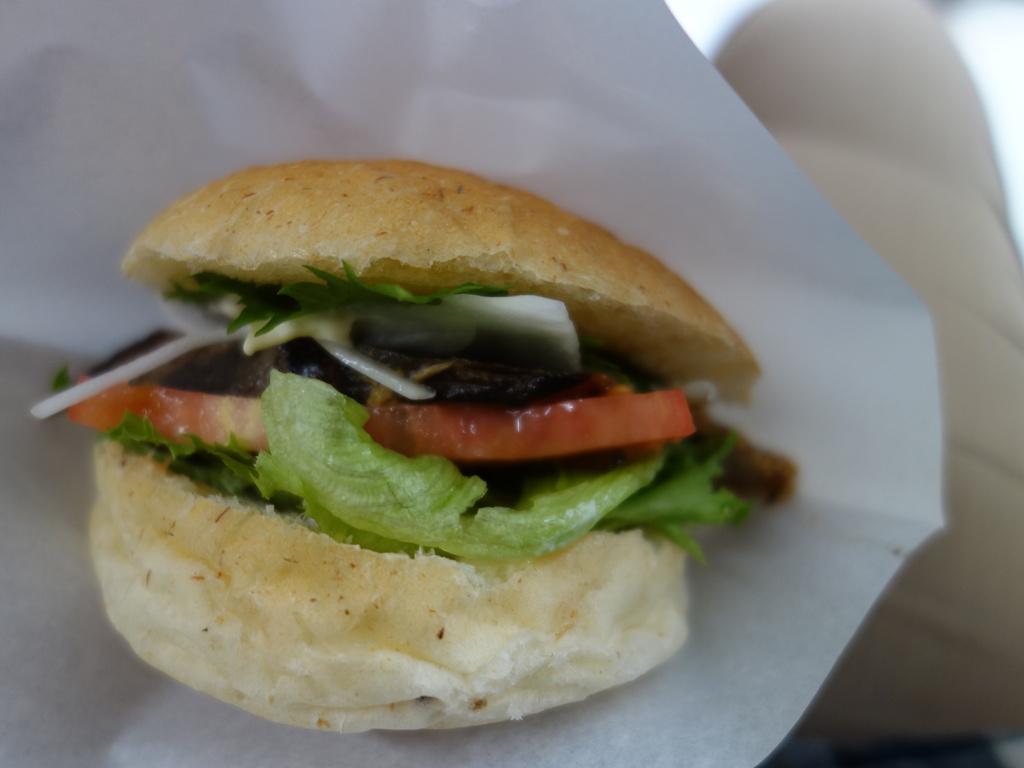Please provide a concise description of this image. In this image there is a burger on a white paper. The background is blurry. 